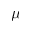<formula> <loc_0><loc_0><loc_500><loc_500>\mu</formula> 